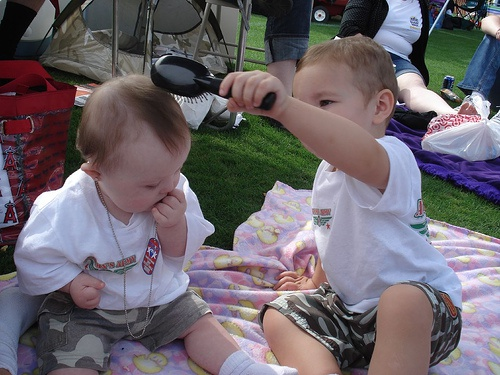Describe the objects in this image and their specific colors. I can see people in lightblue, darkgray, and gray tones, people in lightblue, gray, darkgray, and black tones, handbag in lightblue, maroon, black, gray, and purple tones, people in lightblue, black, white, and darkgray tones, and people in lightblue, black, and gray tones in this image. 